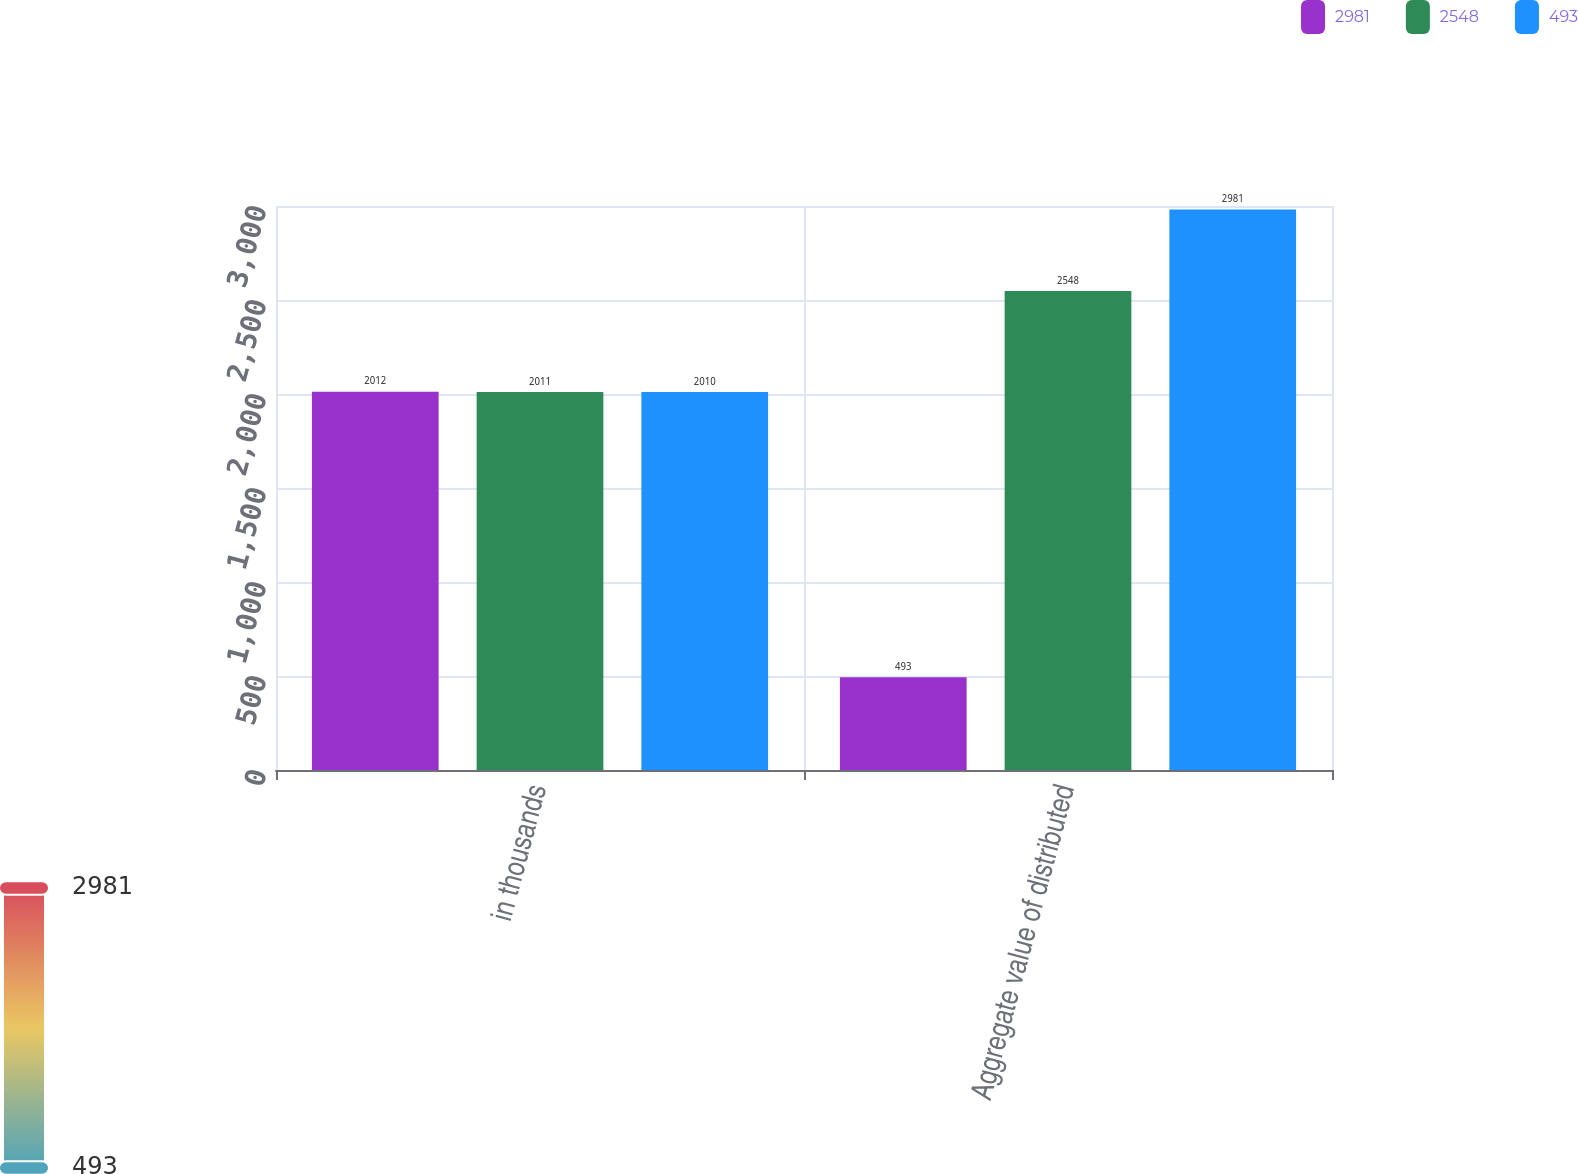<chart> <loc_0><loc_0><loc_500><loc_500><stacked_bar_chart><ecel><fcel>in thousands<fcel>Aggregate value of distributed<nl><fcel>2981<fcel>2012<fcel>493<nl><fcel>2548<fcel>2011<fcel>2548<nl><fcel>493<fcel>2010<fcel>2981<nl></chart> 